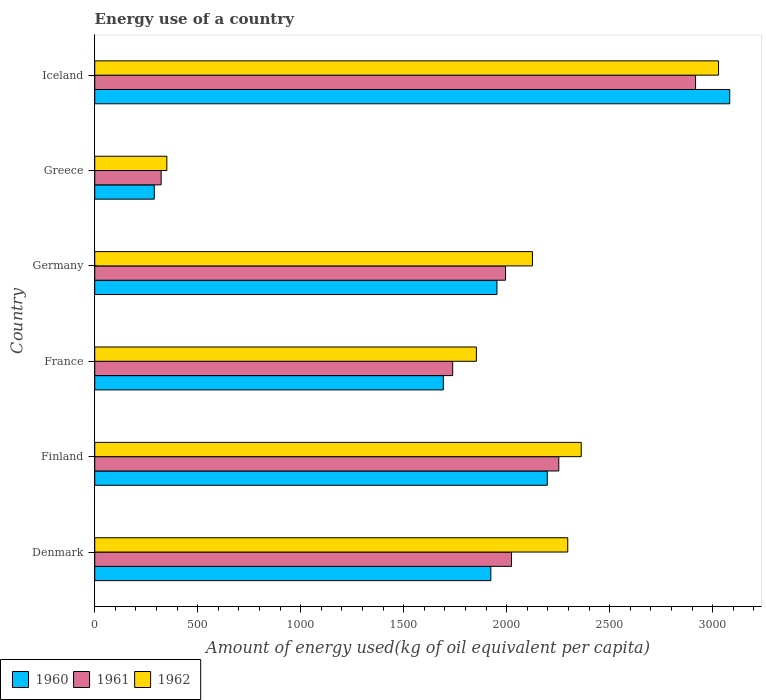How many different coloured bars are there?
Ensure brevity in your answer.  3. How many groups of bars are there?
Make the answer very short. 6. Are the number of bars on each tick of the Y-axis equal?
Give a very brief answer. Yes. In how many cases, is the number of bars for a given country not equal to the number of legend labels?
Give a very brief answer. 0. What is the amount of energy used in in 1962 in Finland?
Provide a short and direct response. 2361.74. Across all countries, what is the maximum amount of energy used in in 1960?
Give a very brief answer. 3082.71. Across all countries, what is the minimum amount of energy used in in 1961?
Keep it short and to the point. 322.49. In which country was the amount of energy used in in 1960 minimum?
Your response must be concise. Greece. What is the total amount of energy used in in 1960 in the graph?
Give a very brief answer. 1.11e+04. What is the difference between the amount of energy used in in 1961 in Denmark and that in Finland?
Offer a very short reply. -229.47. What is the difference between the amount of energy used in in 1960 in Germany and the amount of energy used in in 1962 in Finland?
Provide a short and direct response. -409.16. What is the average amount of energy used in in 1961 per country?
Your answer should be compact. 1874.55. What is the difference between the amount of energy used in in 1961 and amount of energy used in in 1962 in France?
Offer a terse response. -115.05. What is the ratio of the amount of energy used in in 1960 in France to that in Iceland?
Provide a short and direct response. 0.55. Is the amount of energy used in in 1961 in Denmark less than that in Finland?
Provide a succinct answer. Yes. Is the difference between the amount of energy used in in 1961 in Greece and Iceland greater than the difference between the amount of energy used in in 1962 in Greece and Iceland?
Provide a short and direct response. Yes. What is the difference between the highest and the second highest amount of energy used in in 1961?
Provide a short and direct response. 663.93. What is the difference between the highest and the lowest amount of energy used in in 1962?
Provide a succinct answer. 2678.2. In how many countries, is the amount of energy used in in 1962 greater than the average amount of energy used in in 1962 taken over all countries?
Offer a very short reply. 4. What does the 1st bar from the top in France represents?
Give a very brief answer. 1962. Are all the bars in the graph horizontal?
Keep it short and to the point. Yes. How many countries are there in the graph?
Make the answer very short. 6. What is the difference between two consecutive major ticks on the X-axis?
Keep it short and to the point. 500. Does the graph contain any zero values?
Ensure brevity in your answer.  No. Where does the legend appear in the graph?
Offer a very short reply. Bottom left. What is the title of the graph?
Ensure brevity in your answer.  Energy use of a country. Does "1988" appear as one of the legend labels in the graph?
Provide a short and direct response. No. What is the label or title of the X-axis?
Your answer should be very brief. Amount of energy used(kg of oil equivalent per capita). What is the Amount of energy used(kg of oil equivalent per capita) in 1960 in Denmark?
Provide a short and direct response. 1922.97. What is the Amount of energy used(kg of oil equivalent per capita) of 1961 in Denmark?
Your answer should be very brief. 2023.31. What is the Amount of energy used(kg of oil equivalent per capita) of 1962 in Denmark?
Make the answer very short. 2296.29. What is the Amount of energy used(kg of oil equivalent per capita) in 1960 in Finland?
Give a very brief answer. 2196.95. What is the Amount of energy used(kg of oil equivalent per capita) in 1961 in Finland?
Your answer should be very brief. 2252.78. What is the Amount of energy used(kg of oil equivalent per capita) of 1962 in Finland?
Give a very brief answer. 2361.74. What is the Amount of energy used(kg of oil equivalent per capita) in 1960 in France?
Give a very brief answer. 1692.26. What is the Amount of energy used(kg of oil equivalent per capita) of 1961 in France?
Your answer should be compact. 1737.69. What is the Amount of energy used(kg of oil equivalent per capita) of 1962 in France?
Offer a terse response. 1852.74. What is the Amount of energy used(kg of oil equivalent per capita) in 1960 in Germany?
Your answer should be compact. 1952.59. What is the Amount of energy used(kg of oil equivalent per capita) in 1961 in Germany?
Keep it short and to the point. 1994.32. What is the Amount of energy used(kg of oil equivalent per capita) of 1962 in Germany?
Ensure brevity in your answer.  2124.85. What is the Amount of energy used(kg of oil equivalent per capita) of 1960 in Greece?
Offer a terse response. 289.06. What is the Amount of energy used(kg of oil equivalent per capita) of 1961 in Greece?
Provide a short and direct response. 322.49. What is the Amount of energy used(kg of oil equivalent per capita) in 1962 in Greece?
Give a very brief answer. 350.1. What is the Amount of energy used(kg of oil equivalent per capita) in 1960 in Iceland?
Provide a succinct answer. 3082.71. What is the Amount of energy used(kg of oil equivalent per capita) in 1961 in Iceland?
Your answer should be very brief. 2916.71. What is the Amount of energy used(kg of oil equivalent per capita) in 1962 in Iceland?
Your answer should be compact. 3028.3. Across all countries, what is the maximum Amount of energy used(kg of oil equivalent per capita) of 1960?
Your answer should be very brief. 3082.71. Across all countries, what is the maximum Amount of energy used(kg of oil equivalent per capita) of 1961?
Keep it short and to the point. 2916.71. Across all countries, what is the maximum Amount of energy used(kg of oil equivalent per capita) in 1962?
Ensure brevity in your answer.  3028.3. Across all countries, what is the minimum Amount of energy used(kg of oil equivalent per capita) in 1960?
Your answer should be very brief. 289.06. Across all countries, what is the minimum Amount of energy used(kg of oil equivalent per capita) in 1961?
Your response must be concise. 322.49. Across all countries, what is the minimum Amount of energy used(kg of oil equivalent per capita) of 1962?
Offer a very short reply. 350.1. What is the total Amount of energy used(kg of oil equivalent per capita) of 1960 in the graph?
Offer a terse response. 1.11e+04. What is the total Amount of energy used(kg of oil equivalent per capita) in 1961 in the graph?
Your response must be concise. 1.12e+04. What is the total Amount of energy used(kg of oil equivalent per capita) of 1962 in the graph?
Your answer should be very brief. 1.20e+04. What is the difference between the Amount of energy used(kg of oil equivalent per capita) in 1960 in Denmark and that in Finland?
Keep it short and to the point. -273.98. What is the difference between the Amount of energy used(kg of oil equivalent per capita) in 1961 in Denmark and that in Finland?
Make the answer very short. -229.47. What is the difference between the Amount of energy used(kg of oil equivalent per capita) of 1962 in Denmark and that in Finland?
Your answer should be compact. -65.45. What is the difference between the Amount of energy used(kg of oil equivalent per capita) of 1960 in Denmark and that in France?
Offer a terse response. 230.71. What is the difference between the Amount of energy used(kg of oil equivalent per capita) of 1961 in Denmark and that in France?
Your answer should be very brief. 285.62. What is the difference between the Amount of energy used(kg of oil equivalent per capita) of 1962 in Denmark and that in France?
Your answer should be very brief. 443.55. What is the difference between the Amount of energy used(kg of oil equivalent per capita) in 1960 in Denmark and that in Germany?
Your answer should be compact. -29.61. What is the difference between the Amount of energy used(kg of oil equivalent per capita) in 1961 in Denmark and that in Germany?
Offer a very short reply. 28.98. What is the difference between the Amount of energy used(kg of oil equivalent per capita) of 1962 in Denmark and that in Germany?
Ensure brevity in your answer.  171.44. What is the difference between the Amount of energy used(kg of oil equivalent per capita) of 1960 in Denmark and that in Greece?
Your response must be concise. 1633.92. What is the difference between the Amount of energy used(kg of oil equivalent per capita) of 1961 in Denmark and that in Greece?
Make the answer very short. 1700.82. What is the difference between the Amount of energy used(kg of oil equivalent per capita) in 1962 in Denmark and that in Greece?
Your answer should be compact. 1946.19. What is the difference between the Amount of energy used(kg of oil equivalent per capita) of 1960 in Denmark and that in Iceland?
Give a very brief answer. -1159.74. What is the difference between the Amount of energy used(kg of oil equivalent per capita) of 1961 in Denmark and that in Iceland?
Your response must be concise. -893.4. What is the difference between the Amount of energy used(kg of oil equivalent per capita) in 1962 in Denmark and that in Iceland?
Provide a succinct answer. -732.01. What is the difference between the Amount of energy used(kg of oil equivalent per capita) of 1960 in Finland and that in France?
Make the answer very short. 504.69. What is the difference between the Amount of energy used(kg of oil equivalent per capita) of 1961 in Finland and that in France?
Give a very brief answer. 515.09. What is the difference between the Amount of energy used(kg of oil equivalent per capita) of 1962 in Finland and that in France?
Your response must be concise. 509.01. What is the difference between the Amount of energy used(kg of oil equivalent per capita) of 1960 in Finland and that in Germany?
Provide a succinct answer. 244.36. What is the difference between the Amount of energy used(kg of oil equivalent per capita) of 1961 in Finland and that in Germany?
Ensure brevity in your answer.  258.45. What is the difference between the Amount of energy used(kg of oil equivalent per capita) in 1962 in Finland and that in Germany?
Your answer should be compact. 236.9. What is the difference between the Amount of energy used(kg of oil equivalent per capita) of 1960 in Finland and that in Greece?
Keep it short and to the point. 1907.9. What is the difference between the Amount of energy used(kg of oil equivalent per capita) of 1961 in Finland and that in Greece?
Give a very brief answer. 1930.29. What is the difference between the Amount of energy used(kg of oil equivalent per capita) in 1962 in Finland and that in Greece?
Provide a succinct answer. 2011.64. What is the difference between the Amount of energy used(kg of oil equivalent per capita) in 1960 in Finland and that in Iceland?
Give a very brief answer. -885.76. What is the difference between the Amount of energy used(kg of oil equivalent per capita) of 1961 in Finland and that in Iceland?
Give a very brief answer. -663.93. What is the difference between the Amount of energy used(kg of oil equivalent per capita) of 1962 in Finland and that in Iceland?
Offer a very short reply. -666.55. What is the difference between the Amount of energy used(kg of oil equivalent per capita) in 1960 in France and that in Germany?
Offer a very short reply. -260.33. What is the difference between the Amount of energy used(kg of oil equivalent per capita) in 1961 in France and that in Germany?
Your answer should be compact. -256.64. What is the difference between the Amount of energy used(kg of oil equivalent per capita) of 1962 in France and that in Germany?
Offer a very short reply. -272.11. What is the difference between the Amount of energy used(kg of oil equivalent per capita) in 1960 in France and that in Greece?
Keep it short and to the point. 1403.2. What is the difference between the Amount of energy used(kg of oil equivalent per capita) of 1961 in France and that in Greece?
Offer a very short reply. 1415.2. What is the difference between the Amount of energy used(kg of oil equivalent per capita) in 1962 in France and that in Greece?
Offer a very short reply. 1502.63. What is the difference between the Amount of energy used(kg of oil equivalent per capita) of 1960 in France and that in Iceland?
Your answer should be compact. -1390.45. What is the difference between the Amount of energy used(kg of oil equivalent per capita) in 1961 in France and that in Iceland?
Ensure brevity in your answer.  -1179.02. What is the difference between the Amount of energy used(kg of oil equivalent per capita) of 1962 in France and that in Iceland?
Your answer should be very brief. -1175.56. What is the difference between the Amount of energy used(kg of oil equivalent per capita) of 1960 in Germany and that in Greece?
Ensure brevity in your answer.  1663.53. What is the difference between the Amount of energy used(kg of oil equivalent per capita) of 1961 in Germany and that in Greece?
Ensure brevity in your answer.  1671.83. What is the difference between the Amount of energy used(kg of oil equivalent per capita) of 1962 in Germany and that in Greece?
Make the answer very short. 1774.75. What is the difference between the Amount of energy used(kg of oil equivalent per capita) of 1960 in Germany and that in Iceland?
Give a very brief answer. -1130.12. What is the difference between the Amount of energy used(kg of oil equivalent per capita) of 1961 in Germany and that in Iceland?
Your answer should be very brief. -922.38. What is the difference between the Amount of energy used(kg of oil equivalent per capita) of 1962 in Germany and that in Iceland?
Provide a succinct answer. -903.45. What is the difference between the Amount of energy used(kg of oil equivalent per capita) in 1960 in Greece and that in Iceland?
Provide a short and direct response. -2793.65. What is the difference between the Amount of energy used(kg of oil equivalent per capita) of 1961 in Greece and that in Iceland?
Keep it short and to the point. -2594.22. What is the difference between the Amount of energy used(kg of oil equivalent per capita) of 1962 in Greece and that in Iceland?
Provide a succinct answer. -2678.2. What is the difference between the Amount of energy used(kg of oil equivalent per capita) of 1960 in Denmark and the Amount of energy used(kg of oil equivalent per capita) of 1961 in Finland?
Provide a succinct answer. -329.81. What is the difference between the Amount of energy used(kg of oil equivalent per capita) in 1960 in Denmark and the Amount of energy used(kg of oil equivalent per capita) in 1962 in Finland?
Your answer should be compact. -438.77. What is the difference between the Amount of energy used(kg of oil equivalent per capita) in 1961 in Denmark and the Amount of energy used(kg of oil equivalent per capita) in 1962 in Finland?
Your answer should be compact. -338.44. What is the difference between the Amount of energy used(kg of oil equivalent per capita) of 1960 in Denmark and the Amount of energy used(kg of oil equivalent per capita) of 1961 in France?
Give a very brief answer. 185.28. What is the difference between the Amount of energy used(kg of oil equivalent per capita) of 1960 in Denmark and the Amount of energy used(kg of oil equivalent per capita) of 1962 in France?
Your answer should be very brief. 70.24. What is the difference between the Amount of energy used(kg of oil equivalent per capita) of 1961 in Denmark and the Amount of energy used(kg of oil equivalent per capita) of 1962 in France?
Offer a terse response. 170.57. What is the difference between the Amount of energy used(kg of oil equivalent per capita) in 1960 in Denmark and the Amount of energy used(kg of oil equivalent per capita) in 1961 in Germany?
Your response must be concise. -71.35. What is the difference between the Amount of energy used(kg of oil equivalent per capita) in 1960 in Denmark and the Amount of energy used(kg of oil equivalent per capita) in 1962 in Germany?
Your answer should be compact. -201.87. What is the difference between the Amount of energy used(kg of oil equivalent per capita) in 1961 in Denmark and the Amount of energy used(kg of oil equivalent per capita) in 1962 in Germany?
Give a very brief answer. -101.54. What is the difference between the Amount of energy used(kg of oil equivalent per capita) of 1960 in Denmark and the Amount of energy used(kg of oil equivalent per capita) of 1961 in Greece?
Make the answer very short. 1600.48. What is the difference between the Amount of energy used(kg of oil equivalent per capita) of 1960 in Denmark and the Amount of energy used(kg of oil equivalent per capita) of 1962 in Greece?
Give a very brief answer. 1572.87. What is the difference between the Amount of energy used(kg of oil equivalent per capita) of 1961 in Denmark and the Amount of energy used(kg of oil equivalent per capita) of 1962 in Greece?
Your response must be concise. 1673.21. What is the difference between the Amount of energy used(kg of oil equivalent per capita) of 1960 in Denmark and the Amount of energy used(kg of oil equivalent per capita) of 1961 in Iceland?
Keep it short and to the point. -993.73. What is the difference between the Amount of energy used(kg of oil equivalent per capita) in 1960 in Denmark and the Amount of energy used(kg of oil equivalent per capita) in 1962 in Iceland?
Give a very brief answer. -1105.32. What is the difference between the Amount of energy used(kg of oil equivalent per capita) of 1961 in Denmark and the Amount of energy used(kg of oil equivalent per capita) of 1962 in Iceland?
Your answer should be very brief. -1004.99. What is the difference between the Amount of energy used(kg of oil equivalent per capita) of 1960 in Finland and the Amount of energy used(kg of oil equivalent per capita) of 1961 in France?
Keep it short and to the point. 459.26. What is the difference between the Amount of energy used(kg of oil equivalent per capita) in 1960 in Finland and the Amount of energy used(kg of oil equivalent per capita) in 1962 in France?
Keep it short and to the point. 344.22. What is the difference between the Amount of energy used(kg of oil equivalent per capita) in 1961 in Finland and the Amount of energy used(kg of oil equivalent per capita) in 1962 in France?
Ensure brevity in your answer.  400.04. What is the difference between the Amount of energy used(kg of oil equivalent per capita) in 1960 in Finland and the Amount of energy used(kg of oil equivalent per capita) in 1961 in Germany?
Your answer should be very brief. 202.63. What is the difference between the Amount of energy used(kg of oil equivalent per capita) in 1960 in Finland and the Amount of energy used(kg of oil equivalent per capita) in 1962 in Germany?
Your answer should be very brief. 72.1. What is the difference between the Amount of energy used(kg of oil equivalent per capita) of 1961 in Finland and the Amount of energy used(kg of oil equivalent per capita) of 1962 in Germany?
Your response must be concise. 127.93. What is the difference between the Amount of energy used(kg of oil equivalent per capita) of 1960 in Finland and the Amount of energy used(kg of oil equivalent per capita) of 1961 in Greece?
Your response must be concise. 1874.46. What is the difference between the Amount of energy used(kg of oil equivalent per capita) of 1960 in Finland and the Amount of energy used(kg of oil equivalent per capita) of 1962 in Greece?
Give a very brief answer. 1846.85. What is the difference between the Amount of energy used(kg of oil equivalent per capita) of 1961 in Finland and the Amount of energy used(kg of oil equivalent per capita) of 1962 in Greece?
Keep it short and to the point. 1902.68. What is the difference between the Amount of energy used(kg of oil equivalent per capita) in 1960 in Finland and the Amount of energy used(kg of oil equivalent per capita) in 1961 in Iceland?
Provide a short and direct response. -719.75. What is the difference between the Amount of energy used(kg of oil equivalent per capita) of 1960 in Finland and the Amount of energy used(kg of oil equivalent per capita) of 1962 in Iceland?
Provide a succinct answer. -831.35. What is the difference between the Amount of energy used(kg of oil equivalent per capita) in 1961 in Finland and the Amount of energy used(kg of oil equivalent per capita) in 1962 in Iceland?
Make the answer very short. -775.52. What is the difference between the Amount of energy used(kg of oil equivalent per capita) in 1960 in France and the Amount of energy used(kg of oil equivalent per capita) in 1961 in Germany?
Offer a terse response. -302.06. What is the difference between the Amount of energy used(kg of oil equivalent per capita) of 1960 in France and the Amount of energy used(kg of oil equivalent per capita) of 1962 in Germany?
Offer a very short reply. -432.59. What is the difference between the Amount of energy used(kg of oil equivalent per capita) of 1961 in France and the Amount of energy used(kg of oil equivalent per capita) of 1962 in Germany?
Your answer should be compact. -387.16. What is the difference between the Amount of energy used(kg of oil equivalent per capita) of 1960 in France and the Amount of energy used(kg of oil equivalent per capita) of 1961 in Greece?
Make the answer very short. 1369.77. What is the difference between the Amount of energy used(kg of oil equivalent per capita) of 1960 in France and the Amount of energy used(kg of oil equivalent per capita) of 1962 in Greece?
Provide a succinct answer. 1342.16. What is the difference between the Amount of energy used(kg of oil equivalent per capita) of 1961 in France and the Amount of energy used(kg of oil equivalent per capita) of 1962 in Greece?
Keep it short and to the point. 1387.59. What is the difference between the Amount of energy used(kg of oil equivalent per capita) in 1960 in France and the Amount of energy used(kg of oil equivalent per capita) in 1961 in Iceland?
Keep it short and to the point. -1224.44. What is the difference between the Amount of energy used(kg of oil equivalent per capita) of 1960 in France and the Amount of energy used(kg of oil equivalent per capita) of 1962 in Iceland?
Offer a terse response. -1336.04. What is the difference between the Amount of energy used(kg of oil equivalent per capita) in 1961 in France and the Amount of energy used(kg of oil equivalent per capita) in 1962 in Iceland?
Provide a succinct answer. -1290.61. What is the difference between the Amount of energy used(kg of oil equivalent per capita) in 1960 in Germany and the Amount of energy used(kg of oil equivalent per capita) in 1961 in Greece?
Offer a terse response. 1630.1. What is the difference between the Amount of energy used(kg of oil equivalent per capita) in 1960 in Germany and the Amount of energy used(kg of oil equivalent per capita) in 1962 in Greece?
Provide a succinct answer. 1602.49. What is the difference between the Amount of energy used(kg of oil equivalent per capita) of 1961 in Germany and the Amount of energy used(kg of oil equivalent per capita) of 1962 in Greece?
Ensure brevity in your answer.  1644.22. What is the difference between the Amount of energy used(kg of oil equivalent per capita) of 1960 in Germany and the Amount of energy used(kg of oil equivalent per capita) of 1961 in Iceland?
Make the answer very short. -964.12. What is the difference between the Amount of energy used(kg of oil equivalent per capita) in 1960 in Germany and the Amount of energy used(kg of oil equivalent per capita) in 1962 in Iceland?
Your response must be concise. -1075.71. What is the difference between the Amount of energy used(kg of oil equivalent per capita) of 1961 in Germany and the Amount of energy used(kg of oil equivalent per capita) of 1962 in Iceland?
Your answer should be compact. -1033.97. What is the difference between the Amount of energy used(kg of oil equivalent per capita) of 1960 in Greece and the Amount of energy used(kg of oil equivalent per capita) of 1961 in Iceland?
Your answer should be compact. -2627.65. What is the difference between the Amount of energy used(kg of oil equivalent per capita) of 1960 in Greece and the Amount of energy used(kg of oil equivalent per capita) of 1962 in Iceland?
Provide a short and direct response. -2739.24. What is the difference between the Amount of energy used(kg of oil equivalent per capita) in 1961 in Greece and the Amount of energy used(kg of oil equivalent per capita) in 1962 in Iceland?
Ensure brevity in your answer.  -2705.81. What is the average Amount of energy used(kg of oil equivalent per capita) of 1960 per country?
Your answer should be compact. 1856.09. What is the average Amount of energy used(kg of oil equivalent per capita) in 1961 per country?
Your answer should be very brief. 1874.55. What is the average Amount of energy used(kg of oil equivalent per capita) in 1962 per country?
Your answer should be very brief. 2002.34. What is the difference between the Amount of energy used(kg of oil equivalent per capita) in 1960 and Amount of energy used(kg of oil equivalent per capita) in 1961 in Denmark?
Give a very brief answer. -100.33. What is the difference between the Amount of energy used(kg of oil equivalent per capita) in 1960 and Amount of energy used(kg of oil equivalent per capita) in 1962 in Denmark?
Provide a succinct answer. -373.32. What is the difference between the Amount of energy used(kg of oil equivalent per capita) of 1961 and Amount of energy used(kg of oil equivalent per capita) of 1962 in Denmark?
Keep it short and to the point. -272.98. What is the difference between the Amount of energy used(kg of oil equivalent per capita) in 1960 and Amount of energy used(kg of oil equivalent per capita) in 1961 in Finland?
Your answer should be very brief. -55.83. What is the difference between the Amount of energy used(kg of oil equivalent per capita) of 1960 and Amount of energy used(kg of oil equivalent per capita) of 1962 in Finland?
Your answer should be very brief. -164.79. What is the difference between the Amount of energy used(kg of oil equivalent per capita) of 1961 and Amount of energy used(kg of oil equivalent per capita) of 1962 in Finland?
Provide a short and direct response. -108.97. What is the difference between the Amount of energy used(kg of oil equivalent per capita) of 1960 and Amount of energy used(kg of oil equivalent per capita) of 1961 in France?
Your answer should be compact. -45.43. What is the difference between the Amount of energy used(kg of oil equivalent per capita) in 1960 and Amount of energy used(kg of oil equivalent per capita) in 1962 in France?
Offer a very short reply. -160.47. What is the difference between the Amount of energy used(kg of oil equivalent per capita) of 1961 and Amount of energy used(kg of oil equivalent per capita) of 1962 in France?
Your answer should be compact. -115.05. What is the difference between the Amount of energy used(kg of oil equivalent per capita) in 1960 and Amount of energy used(kg of oil equivalent per capita) in 1961 in Germany?
Keep it short and to the point. -41.74. What is the difference between the Amount of energy used(kg of oil equivalent per capita) of 1960 and Amount of energy used(kg of oil equivalent per capita) of 1962 in Germany?
Give a very brief answer. -172.26. What is the difference between the Amount of energy used(kg of oil equivalent per capita) in 1961 and Amount of energy used(kg of oil equivalent per capita) in 1962 in Germany?
Ensure brevity in your answer.  -130.52. What is the difference between the Amount of energy used(kg of oil equivalent per capita) of 1960 and Amount of energy used(kg of oil equivalent per capita) of 1961 in Greece?
Offer a very short reply. -33.43. What is the difference between the Amount of energy used(kg of oil equivalent per capita) of 1960 and Amount of energy used(kg of oil equivalent per capita) of 1962 in Greece?
Ensure brevity in your answer.  -61.04. What is the difference between the Amount of energy used(kg of oil equivalent per capita) in 1961 and Amount of energy used(kg of oil equivalent per capita) in 1962 in Greece?
Offer a terse response. -27.61. What is the difference between the Amount of energy used(kg of oil equivalent per capita) in 1960 and Amount of energy used(kg of oil equivalent per capita) in 1961 in Iceland?
Keep it short and to the point. 166.01. What is the difference between the Amount of energy used(kg of oil equivalent per capita) of 1960 and Amount of energy used(kg of oil equivalent per capita) of 1962 in Iceland?
Your answer should be very brief. 54.41. What is the difference between the Amount of energy used(kg of oil equivalent per capita) in 1961 and Amount of energy used(kg of oil equivalent per capita) in 1962 in Iceland?
Provide a short and direct response. -111.59. What is the ratio of the Amount of energy used(kg of oil equivalent per capita) in 1960 in Denmark to that in Finland?
Offer a terse response. 0.88. What is the ratio of the Amount of energy used(kg of oil equivalent per capita) in 1961 in Denmark to that in Finland?
Provide a short and direct response. 0.9. What is the ratio of the Amount of energy used(kg of oil equivalent per capita) in 1962 in Denmark to that in Finland?
Your answer should be compact. 0.97. What is the ratio of the Amount of energy used(kg of oil equivalent per capita) of 1960 in Denmark to that in France?
Provide a short and direct response. 1.14. What is the ratio of the Amount of energy used(kg of oil equivalent per capita) in 1961 in Denmark to that in France?
Keep it short and to the point. 1.16. What is the ratio of the Amount of energy used(kg of oil equivalent per capita) of 1962 in Denmark to that in France?
Your answer should be compact. 1.24. What is the ratio of the Amount of energy used(kg of oil equivalent per capita) of 1960 in Denmark to that in Germany?
Your answer should be very brief. 0.98. What is the ratio of the Amount of energy used(kg of oil equivalent per capita) in 1961 in Denmark to that in Germany?
Your answer should be very brief. 1.01. What is the ratio of the Amount of energy used(kg of oil equivalent per capita) of 1962 in Denmark to that in Germany?
Make the answer very short. 1.08. What is the ratio of the Amount of energy used(kg of oil equivalent per capita) in 1960 in Denmark to that in Greece?
Your response must be concise. 6.65. What is the ratio of the Amount of energy used(kg of oil equivalent per capita) in 1961 in Denmark to that in Greece?
Provide a succinct answer. 6.27. What is the ratio of the Amount of energy used(kg of oil equivalent per capita) of 1962 in Denmark to that in Greece?
Offer a terse response. 6.56. What is the ratio of the Amount of energy used(kg of oil equivalent per capita) of 1960 in Denmark to that in Iceland?
Offer a very short reply. 0.62. What is the ratio of the Amount of energy used(kg of oil equivalent per capita) of 1961 in Denmark to that in Iceland?
Ensure brevity in your answer.  0.69. What is the ratio of the Amount of energy used(kg of oil equivalent per capita) in 1962 in Denmark to that in Iceland?
Offer a very short reply. 0.76. What is the ratio of the Amount of energy used(kg of oil equivalent per capita) in 1960 in Finland to that in France?
Your answer should be very brief. 1.3. What is the ratio of the Amount of energy used(kg of oil equivalent per capita) in 1961 in Finland to that in France?
Your answer should be compact. 1.3. What is the ratio of the Amount of energy used(kg of oil equivalent per capita) of 1962 in Finland to that in France?
Your answer should be compact. 1.27. What is the ratio of the Amount of energy used(kg of oil equivalent per capita) of 1960 in Finland to that in Germany?
Keep it short and to the point. 1.13. What is the ratio of the Amount of energy used(kg of oil equivalent per capita) of 1961 in Finland to that in Germany?
Your answer should be compact. 1.13. What is the ratio of the Amount of energy used(kg of oil equivalent per capita) in 1962 in Finland to that in Germany?
Your answer should be very brief. 1.11. What is the ratio of the Amount of energy used(kg of oil equivalent per capita) of 1960 in Finland to that in Greece?
Provide a short and direct response. 7.6. What is the ratio of the Amount of energy used(kg of oil equivalent per capita) in 1961 in Finland to that in Greece?
Offer a terse response. 6.99. What is the ratio of the Amount of energy used(kg of oil equivalent per capita) in 1962 in Finland to that in Greece?
Give a very brief answer. 6.75. What is the ratio of the Amount of energy used(kg of oil equivalent per capita) in 1960 in Finland to that in Iceland?
Your response must be concise. 0.71. What is the ratio of the Amount of energy used(kg of oil equivalent per capita) of 1961 in Finland to that in Iceland?
Ensure brevity in your answer.  0.77. What is the ratio of the Amount of energy used(kg of oil equivalent per capita) in 1962 in Finland to that in Iceland?
Offer a terse response. 0.78. What is the ratio of the Amount of energy used(kg of oil equivalent per capita) of 1960 in France to that in Germany?
Provide a short and direct response. 0.87. What is the ratio of the Amount of energy used(kg of oil equivalent per capita) of 1961 in France to that in Germany?
Offer a very short reply. 0.87. What is the ratio of the Amount of energy used(kg of oil equivalent per capita) in 1962 in France to that in Germany?
Keep it short and to the point. 0.87. What is the ratio of the Amount of energy used(kg of oil equivalent per capita) of 1960 in France to that in Greece?
Your response must be concise. 5.85. What is the ratio of the Amount of energy used(kg of oil equivalent per capita) of 1961 in France to that in Greece?
Provide a succinct answer. 5.39. What is the ratio of the Amount of energy used(kg of oil equivalent per capita) of 1962 in France to that in Greece?
Ensure brevity in your answer.  5.29. What is the ratio of the Amount of energy used(kg of oil equivalent per capita) in 1960 in France to that in Iceland?
Offer a very short reply. 0.55. What is the ratio of the Amount of energy used(kg of oil equivalent per capita) of 1961 in France to that in Iceland?
Ensure brevity in your answer.  0.6. What is the ratio of the Amount of energy used(kg of oil equivalent per capita) in 1962 in France to that in Iceland?
Keep it short and to the point. 0.61. What is the ratio of the Amount of energy used(kg of oil equivalent per capita) of 1960 in Germany to that in Greece?
Your answer should be compact. 6.75. What is the ratio of the Amount of energy used(kg of oil equivalent per capita) of 1961 in Germany to that in Greece?
Provide a short and direct response. 6.18. What is the ratio of the Amount of energy used(kg of oil equivalent per capita) of 1962 in Germany to that in Greece?
Offer a terse response. 6.07. What is the ratio of the Amount of energy used(kg of oil equivalent per capita) in 1960 in Germany to that in Iceland?
Provide a succinct answer. 0.63. What is the ratio of the Amount of energy used(kg of oil equivalent per capita) of 1961 in Germany to that in Iceland?
Give a very brief answer. 0.68. What is the ratio of the Amount of energy used(kg of oil equivalent per capita) of 1962 in Germany to that in Iceland?
Keep it short and to the point. 0.7. What is the ratio of the Amount of energy used(kg of oil equivalent per capita) in 1960 in Greece to that in Iceland?
Make the answer very short. 0.09. What is the ratio of the Amount of energy used(kg of oil equivalent per capita) of 1961 in Greece to that in Iceland?
Your response must be concise. 0.11. What is the ratio of the Amount of energy used(kg of oil equivalent per capita) in 1962 in Greece to that in Iceland?
Offer a very short reply. 0.12. What is the difference between the highest and the second highest Amount of energy used(kg of oil equivalent per capita) of 1960?
Make the answer very short. 885.76. What is the difference between the highest and the second highest Amount of energy used(kg of oil equivalent per capita) in 1961?
Offer a terse response. 663.93. What is the difference between the highest and the second highest Amount of energy used(kg of oil equivalent per capita) in 1962?
Make the answer very short. 666.55. What is the difference between the highest and the lowest Amount of energy used(kg of oil equivalent per capita) of 1960?
Give a very brief answer. 2793.65. What is the difference between the highest and the lowest Amount of energy used(kg of oil equivalent per capita) of 1961?
Ensure brevity in your answer.  2594.22. What is the difference between the highest and the lowest Amount of energy used(kg of oil equivalent per capita) of 1962?
Ensure brevity in your answer.  2678.2. 